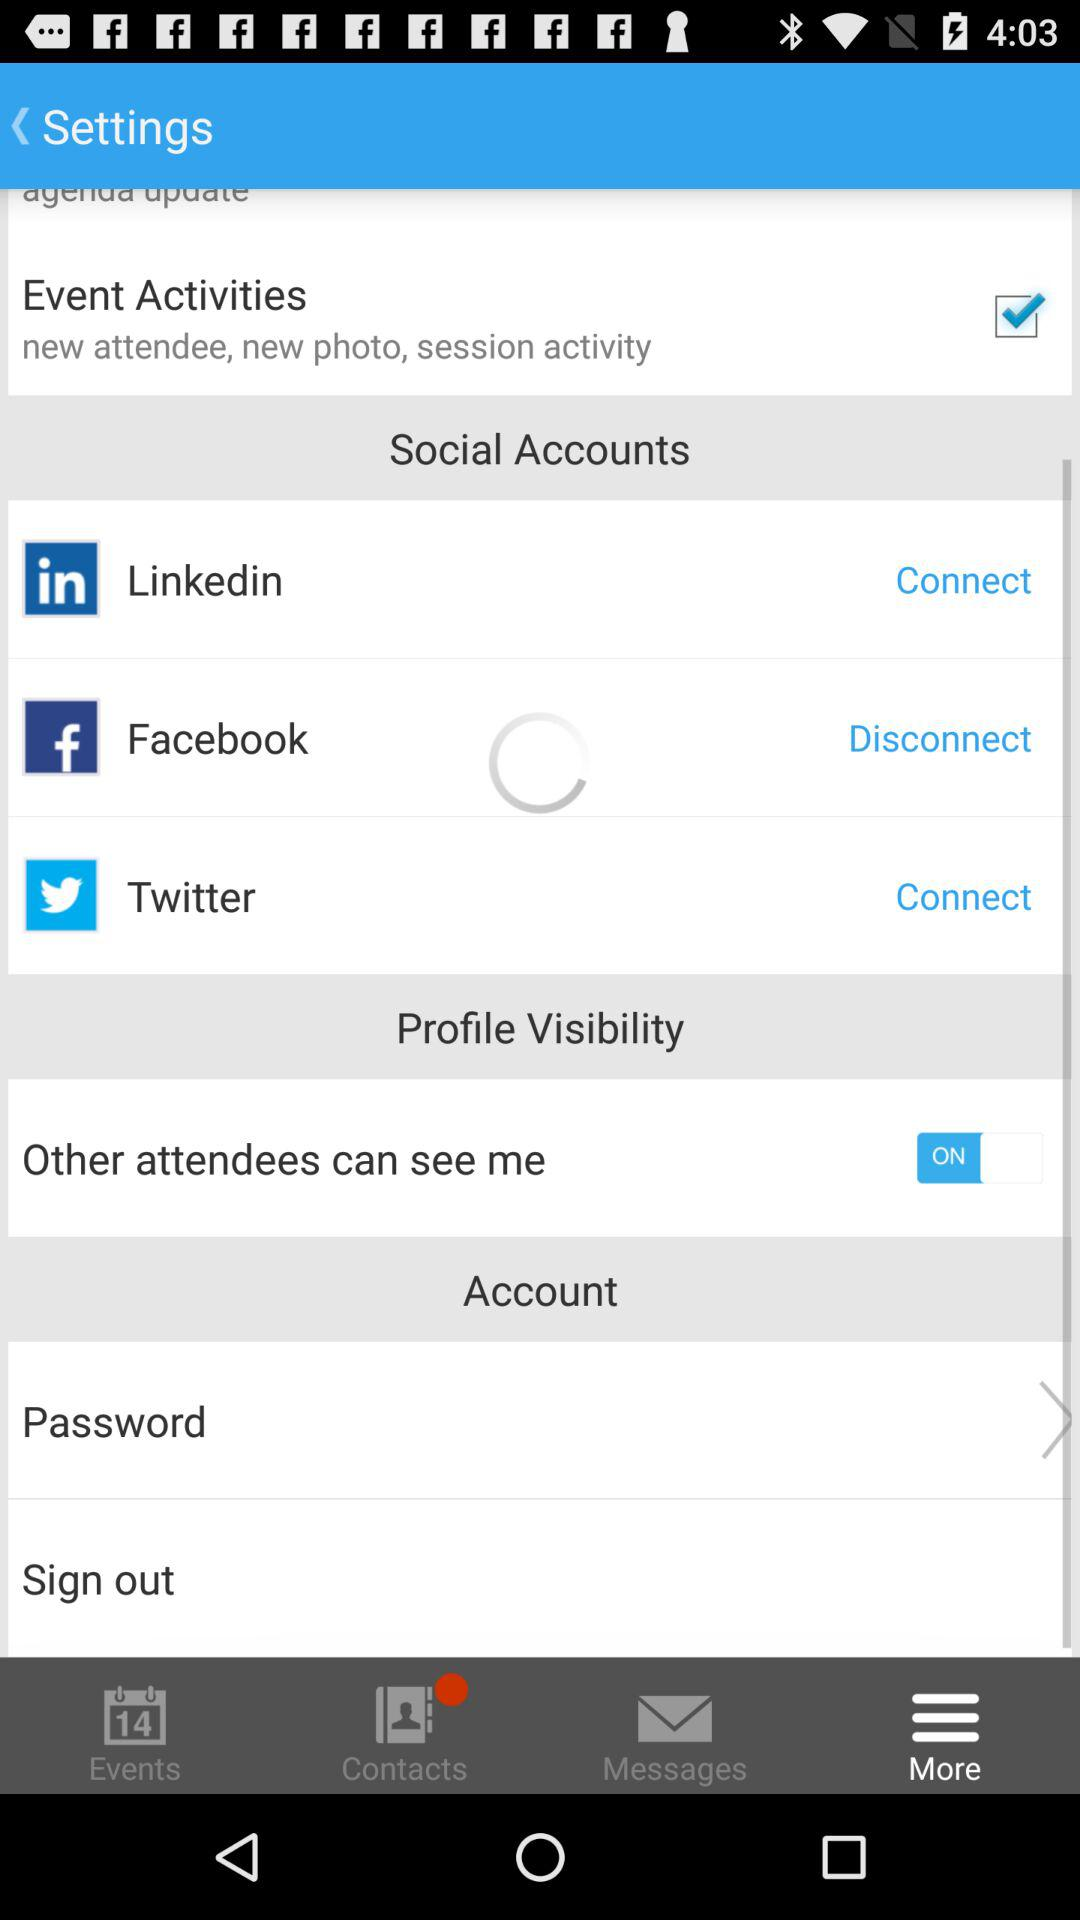What is the current status of the "Event Activities"? The current status of the "Event Activities" is "on". 